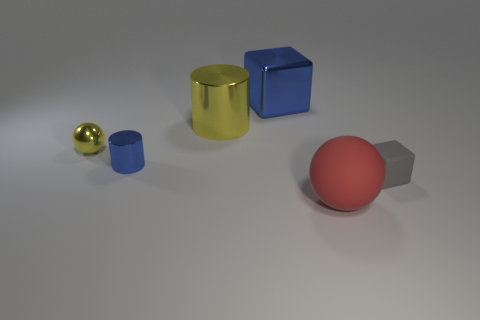Can you describe the lighting in the scene? The lighting in the scene appears to be coming from above, casting soft shadows to the right of the objects, suggesting a diffused light source that provides even illumination across the scene. 